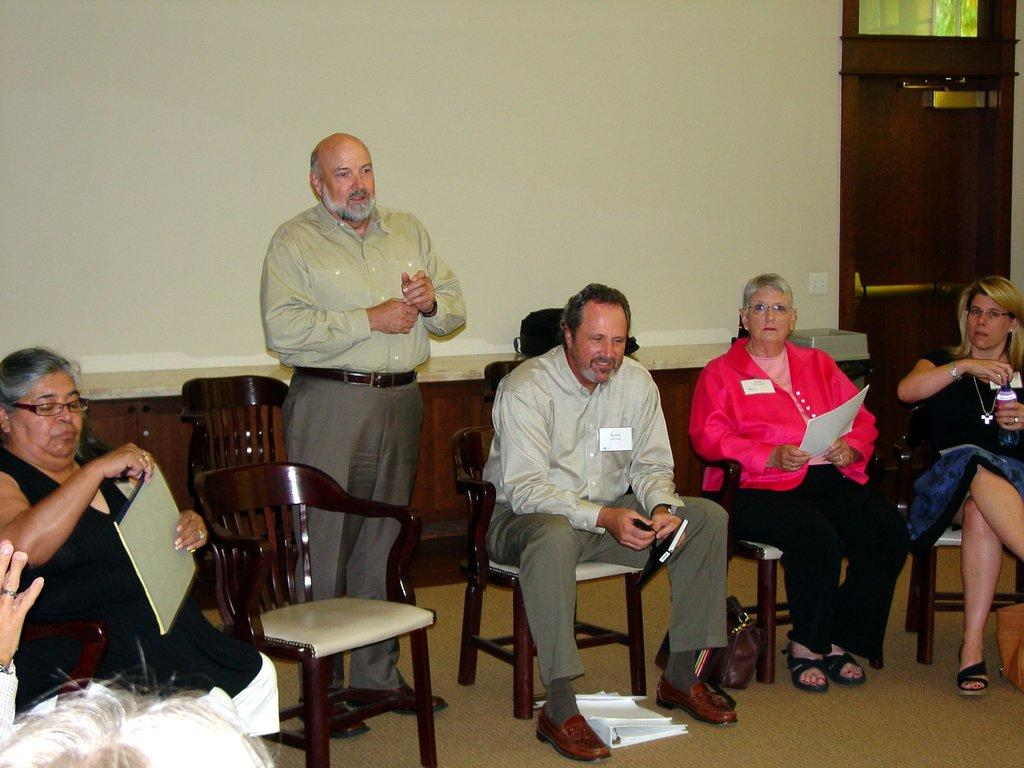What is happening in the image involving a group of people? There is a group of people in the image, and they are sitting on chairs. Can you describe the setting in which the people are sitting? The people are sitting in a setting where there is a person standing in front of a projector screen. What might be the purpose of the person standing in front of the projector screen? The person standing in front of the projector screen might be presenting or giving a talk to the group of people. What type of whistle can be heard in the image? There is no whistle present in the image, and therefore no sound can be heard. 